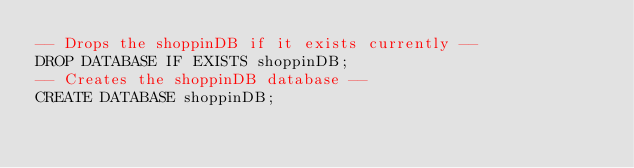Convert code to text. <code><loc_0><loc_0><loc_500><loc_500><_SQL_>-- Drops the shoppinDB if it exists currently --
DROP DATABASE IF EXISTS shoppinDB;
-- Creates the shoppinDB database --
CREATE DATABASE shoppinDB;
</code> 